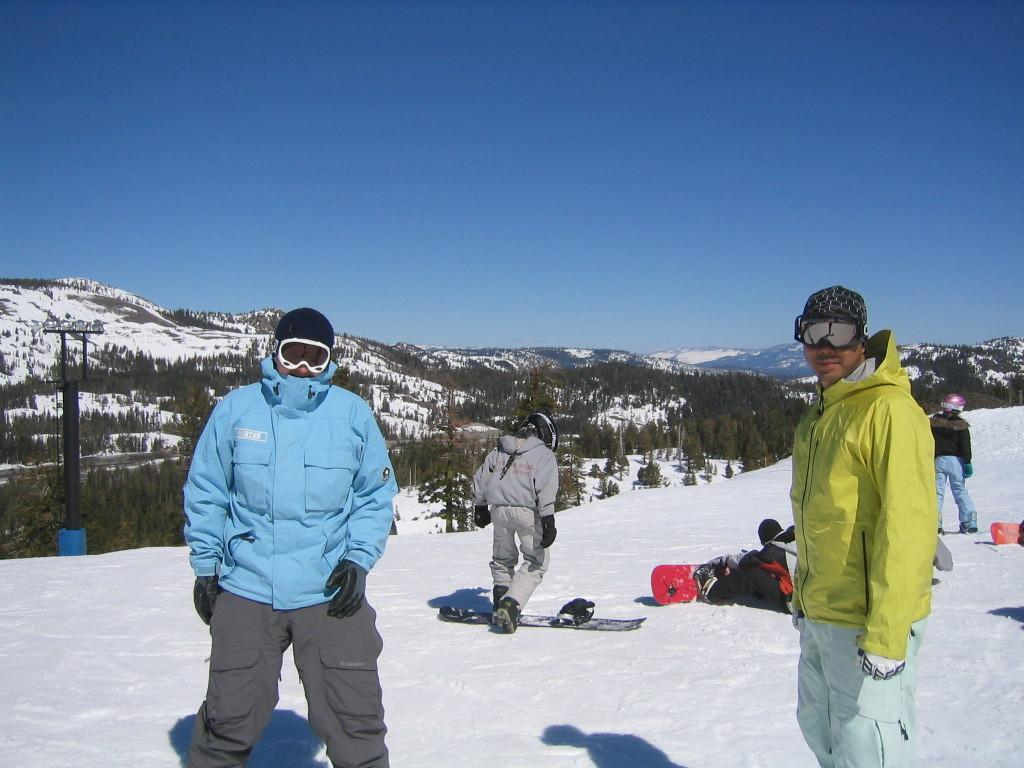How many people are in the image? There are four people in the image. What are the people wearing? The people are wearing jackets. What is the ground made of in the image? The people are standing on snow. What can be seen in the background of the image? There are trees around the people. How many geese are flying in the rainstorm in the image? There is no rainstorm or geese present in the image. What type of cloth is being used to cover the trees in the image? There is no cloth being used to cover the trees in the image; the trees are visible in the background. 